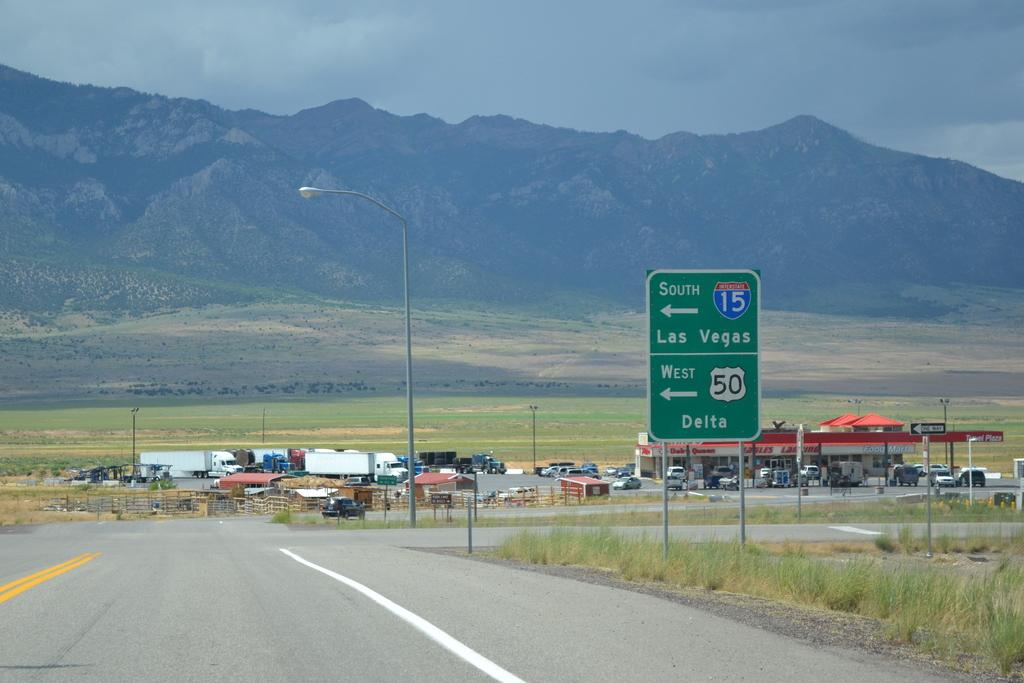<image>
Render a clear and concise summary of the photo. A road sign saying to make a left turn for 15 South to Las Vegas. 